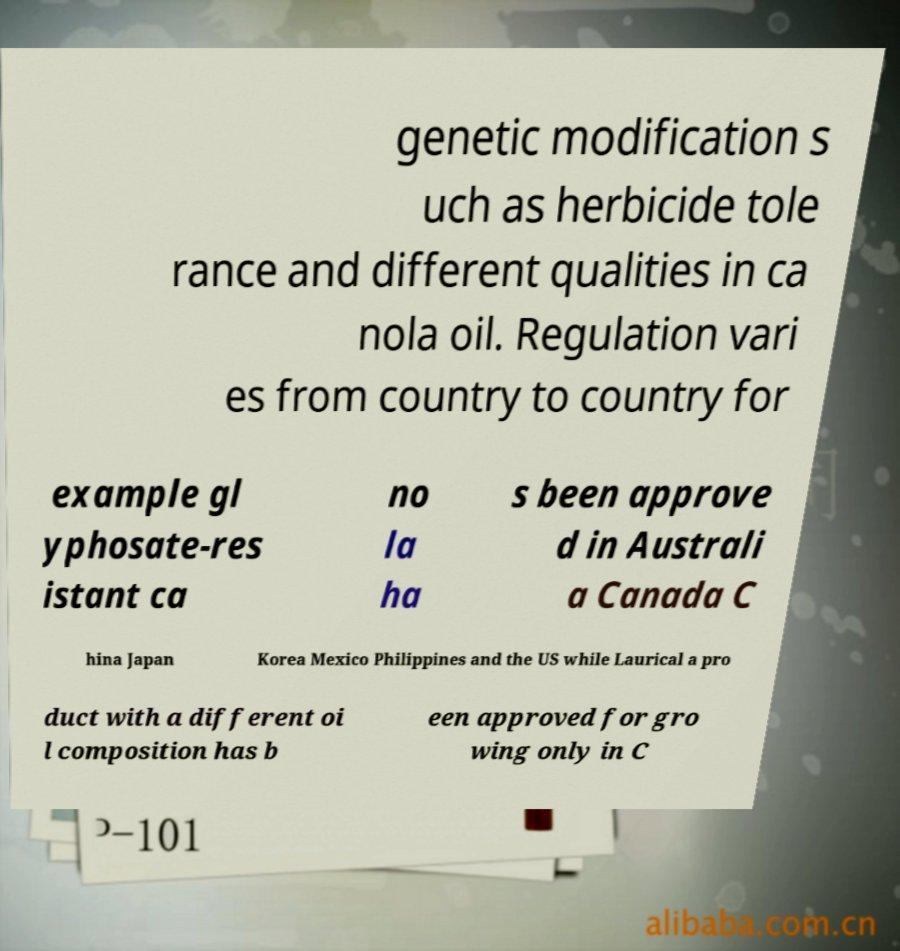Could you extract and type out the text from this image? genetic modification s uch as herbicide tole rance and different qualities in ca nola oil. Regulation vari es from country to country for example gl yphosate-res istant ca no la ha s been approve d in Australi a Canada C hina Japan Korea Mexico Philippines and the US while Laurical a pro duct with a different oi l composition has b een approved for gro wing only in C 